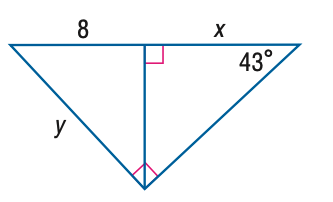Answer the mathemtical geometry problem and directly provide the correct option letter.
Question: Find y. Round to the nearest tenth.
Choices: A: 5.5 B: 8.6 C: 10.9 D: 11.7 D 